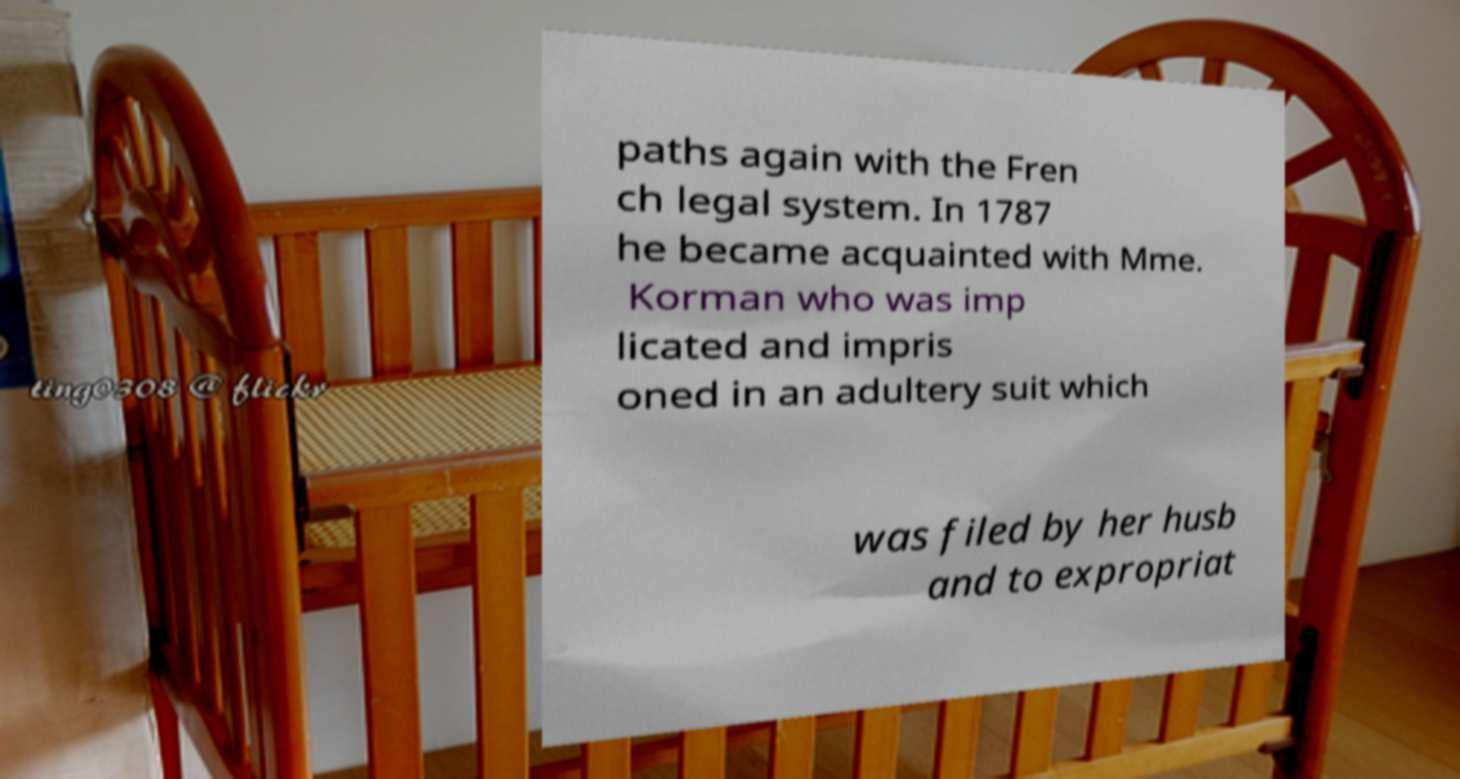What messages or text are displayed in this image? I need them in a readable, typed format. paths again with the Fren ch legal system. In 1787 he became acquainted with Mme. Korman who was imp licated and impris oned in an adultery suit which was filed by her husb and to expropriat 